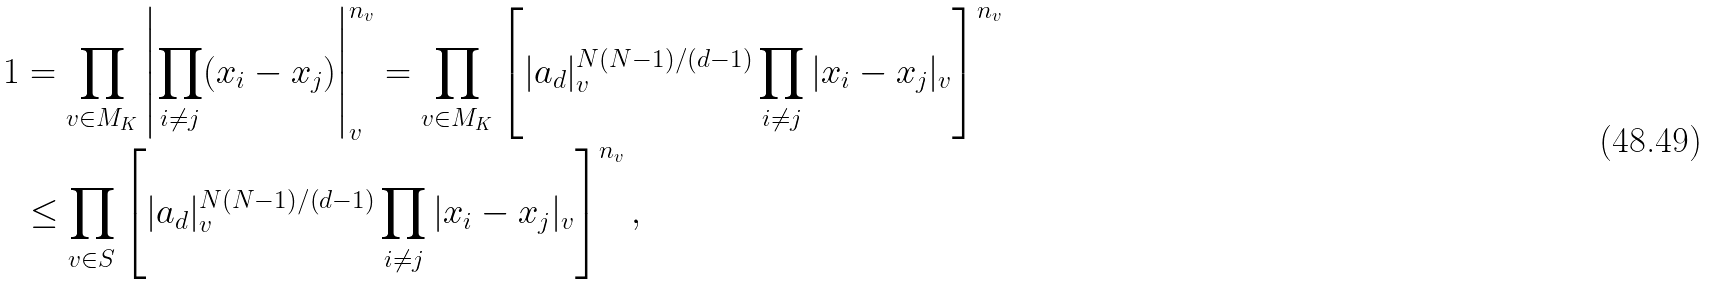<formula> <loc_0><loc_0><loc_500><loc_500>1 & = \prod _ { v \in M _ { K } } \left | \prod _ { i \neq j } ( x _ { i } - x _ { j } ) \right | _ { v } ^ { n _ { v } } = \prod _ { v \in M _ { K } } \left [ | a _ { d } | _ { v } ^ { N ( N - 1 ) / ( d - 1 ) } \prod _ { i \neq j } | x _ { i } - x _ { j } | _ { v } \right ] ^ { n _ { v } } \\ & \leq \prod _ { v \in S } \left [ | a _ { d } | _ { v } ^ { N ( N - 1 ) / ( d - 1 ) } \prod _ { i \neq j } | x _ { i } - x _ { j } | _ { v } \right ] ^ { n _ { v } } ,</formula> 